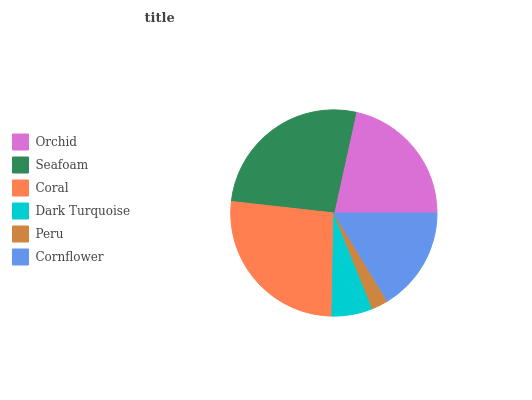Is Peru the minimum?
Answer yes or no. Yes. Is Seafoam the maximum?
Answer yes or no. Yes. Is Coral the minimum?
Answer yes or no. No. Is Coral the maximum?
Answer yes or no. No. Is Seafoam greater than Coral?
Answer yes or no. Yes. Is Coral less than Seafoam?
Answer yes or no. Yes. Is Coral greater than Seafoam?
Answer yes or no. No. Is Seafoam less than Coral?
Answer yes or no. No. Is Orchid the high median?
Answer yes or no. Yes. Is Cornflower the low median?
Answer yes or no. Yes. Is Dark Turquoise the high median?
Answer yes or no. No. Is Orchid the low median?
Answer yes or no. No. 